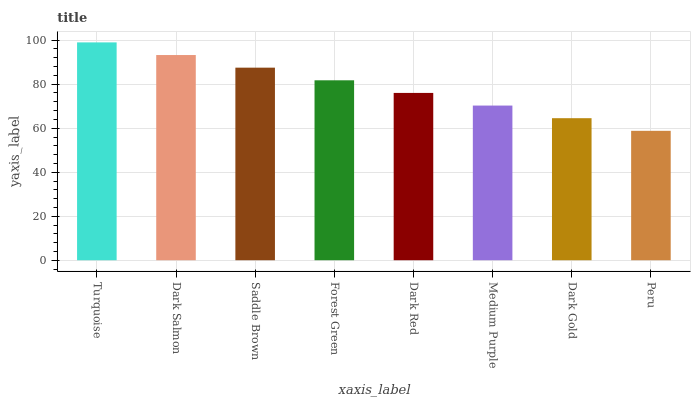Is Peru the minimum?
Answer yes or no. Yes. Is Turquoise the maximum?
Answer yes or no. Yes. Is Dark Salmon the minimum?
Answer yes or no. No. Is Dark Salmon the maximum?
Answer yes or no. No. Is Turquoise greater than Dark Salmon?
Answer yes or no. Yes. Is Dark Salmon less than Turquoise?
Answer yes or no. Yes. Is Dark Salmon greater than Turquoise?
Answer yes or no. No. Is Turquoise less than Dark Salmon?
Answer yes or no. No. Is Forest Green the high median?
Answer yes or no. Yes. Is Dark Red the low median?
Answer yes or no. Yes. Is Saddle Brown the high median?
Answer yes or no. No. Is Turquoise the low median?
Answer yes or no. No. 